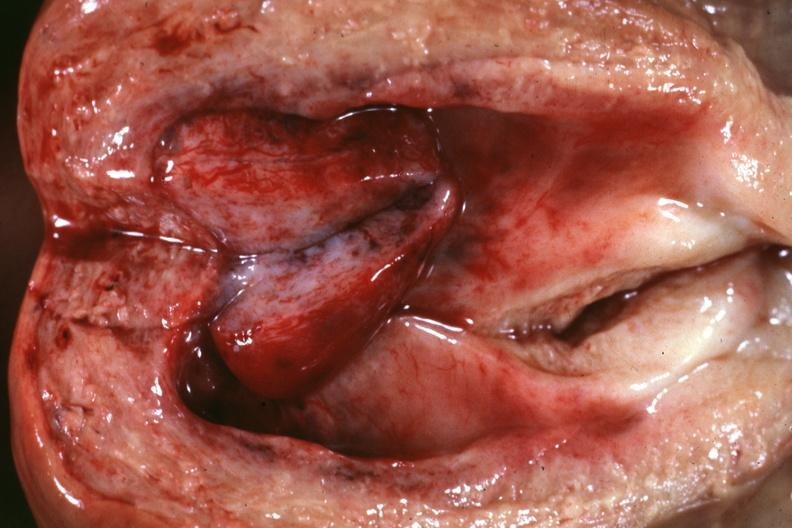does case of dic not bad photo show opened uterus close-up with rather large polyp 66yo diabetic female no tissue diagnosis?
Answer the question using a single word or phrase. No 